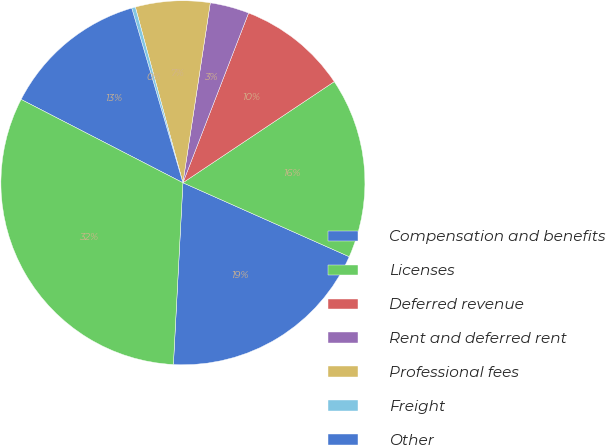Convert chart. <chart><loc_0><loc_0><loc_500><loc_500><pie_chart><fcel>Compensation and benefits<fcel>Licenses<fcel>Deferred revenue<fcel>Rent and deferred rent<fcel>Professional fees<fcel>Freight<fcel>Other<fcel>Total<nl><fcel>19.17%<fcel>16.03%<fcel>9.75%<fcel>3.47%<fcel>6.61%<fcel>0.33%<fcel>12.89%<fcel>31.73%<nl></chart> 